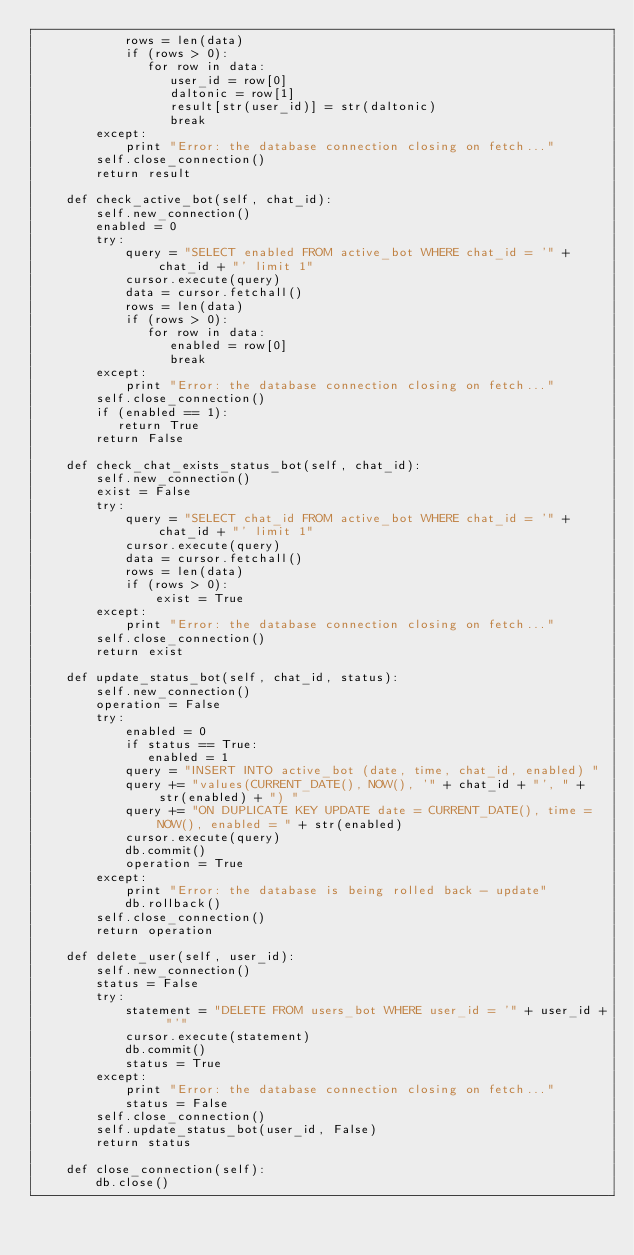Convert code to text. <code><loc_0><loc_0><loc_500><loc_500><_Python_>            rows = len(data)
            if (rows > 0):
               for row in data:
                  user_id = row[0] 
                  daltonic = row[1]
                  result[str(user_id)] = str(daltonic)
                  break              
        except:
            print "Error: the database connection closing on fetch..."
        self.close_connection()
        return result

    def check_active_bot(self, chat_id):
        self.new_connection()
        enabled = 0
        try:
            query = "SELECT enabled FROM active_bot WHERE chat_id = '" + chat_id + "' limit 1"
            cursor.execute(query)
            data = cursor.fetchall()
            rows = len(data)
            if (rows > 0):
               for row in data:
                  enabled = row[0]
                  break
        except:
            print "Error: the database connection closing on fetch..."
        self.close_connection()
        if (enabled == 1):
           return True
        return False

    def check_chat_exists_status_bot(self, chat_id):
        self.new_connection()
        exist = False
        try:
            query = "SELECT chat_id FROM active_bot WHERE chat_id = '" + chat_id + "' limit 1"
            cursor.execute(query)
            data = cursor.fetchall()
            rows = len(data)
            if (rows > 0):
                exist = True
        except:
            print "Error: the database connection closing on fetch..."
        self.close_connection()
        return exist

    def update_status_bot(self, chat_id, status):
        self.new_connection()
        operation = False
        try:
            enabled = 0
            if status == True:
               enabled = 1
            query = "INSERT INTO active_bot (date, time, chat_id, enabled) "
            query += "values(CURRENT_DATE(), NOW(), '" + chat_id + "', " + str(enabled) + ") "
            query += "ON DUPLICATE KEY UPDATE date = CURRENT_DATE(), time = NOW(), enabled = " + str(enabled)
            cursor.execute(query)
            db.commit()
            operation = True
        except:
            print "Error: the database is being rolled back - update"
            db.rollback()
        self.close_connection()
        return operation

    def delete_user(self, user_id):
        self.new_connection()
        status = False
        try:
            statement = "DELETE FROM users_bot WHERE user_id = '" + user_id + "'" 
            cursor.execute(statement)
            db.commit()
            status = True
        except:
            print "Error: the database connection closing on fetch..."
            status = False
        self.close_connection()
        self.update_status_bot(user_id, False)
        return status

    def close_connection(self):
        db.close()
</code> 